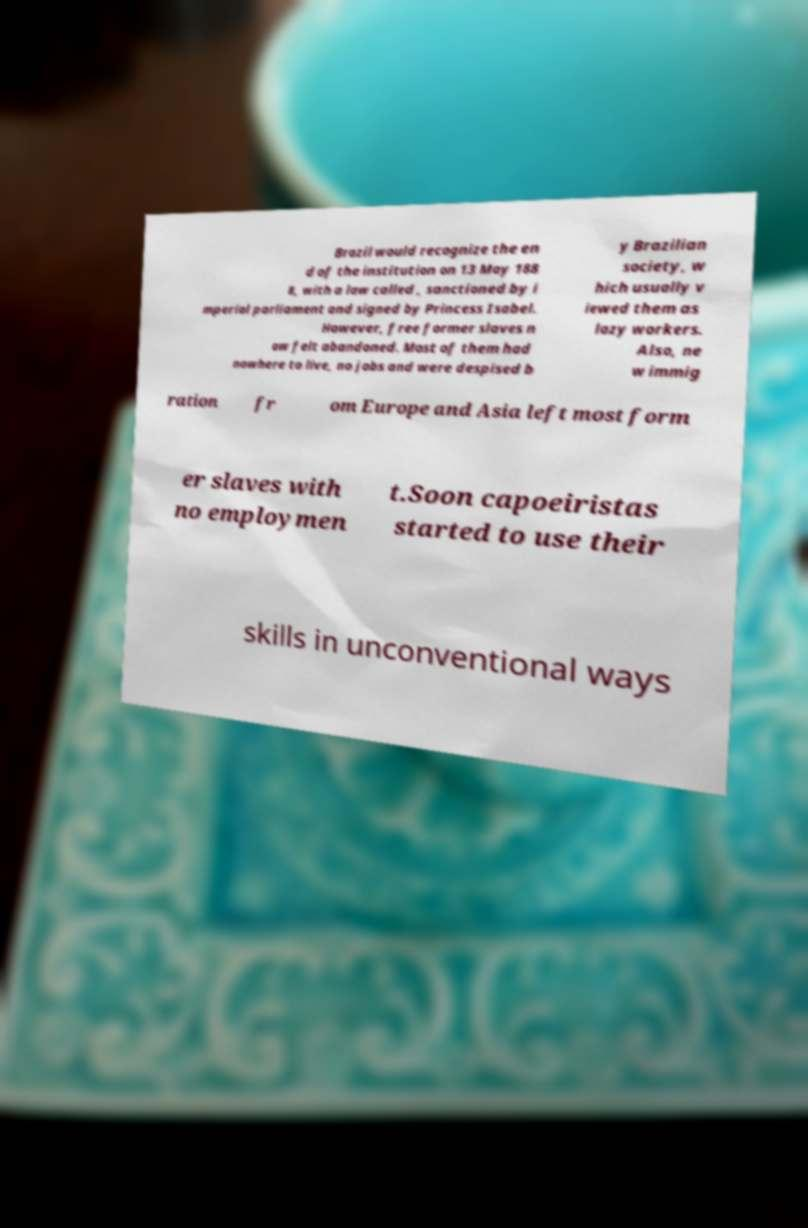There's text embedded in this image that I need extracted. Can you transcribe it verbatim? Brazil would recognize the en d of the institution on 13 May 188 8, with a law called , sanctioned by i mperial parliament and signed by Princess Isabel. However, free former slaves n ow felt abandoned. Most of them had nowhere to live, no jobs and were despised b y Brazilian society, w hich usually v iewed them as lazy workers. Also, ne w immig ration fr om Europe and Asia left most form er slaves with no employmen t.Soon capoeiristas started to use their skills in unconventional ways 